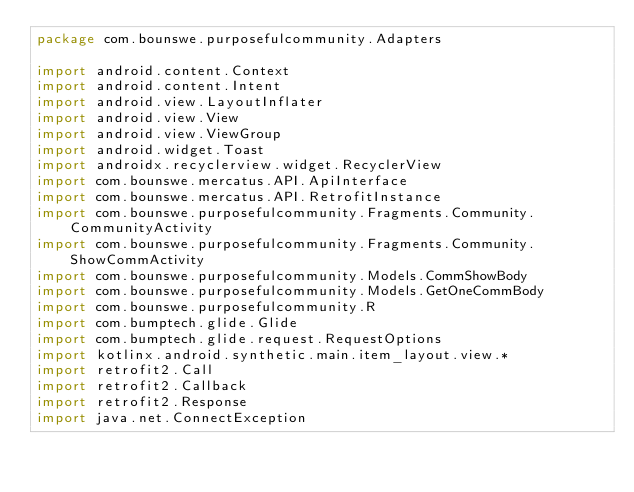Convert code to text. <code><loc_0><loc_0><loc_500><loc_500><_Kotlin_>package com.bounswe.purposefulcommunity.Adapters

import android.content.Context
import android.content.Intent
import android.view.LayoutInflater
import android.view.View
import android.view.ViewGroup
import android.widget.Toast
import androidx.recyclerview.widget.RecyclerView
import com.bounswe.mercatus.API.ApiInterface
import com.bounswe.mercatus.API.RetrofitInstance
import com.bounswe.purposefulcommunity.Fragments.Community.CommunityActivity
import com.bounswe.purposefulcommunity.Fragments.Community.ShowCommActivity
import com.bounswe.purposefulcommunity.Models.CommShowBody
import com.bounswe.purposefulcommunity.Models.GetOneCommBody
import com.bounswe.purposefulcommunity.R
import com.bumptech.glide.Glide
import com.bumptech.glide.request.RequestOptions
import kotlinx.android.synthetic.main.item_layout.view.*
import retrofit2.Call
import retrofit2.Callback
import retrofit2.Response
import java.net.ConnectException
</code> 